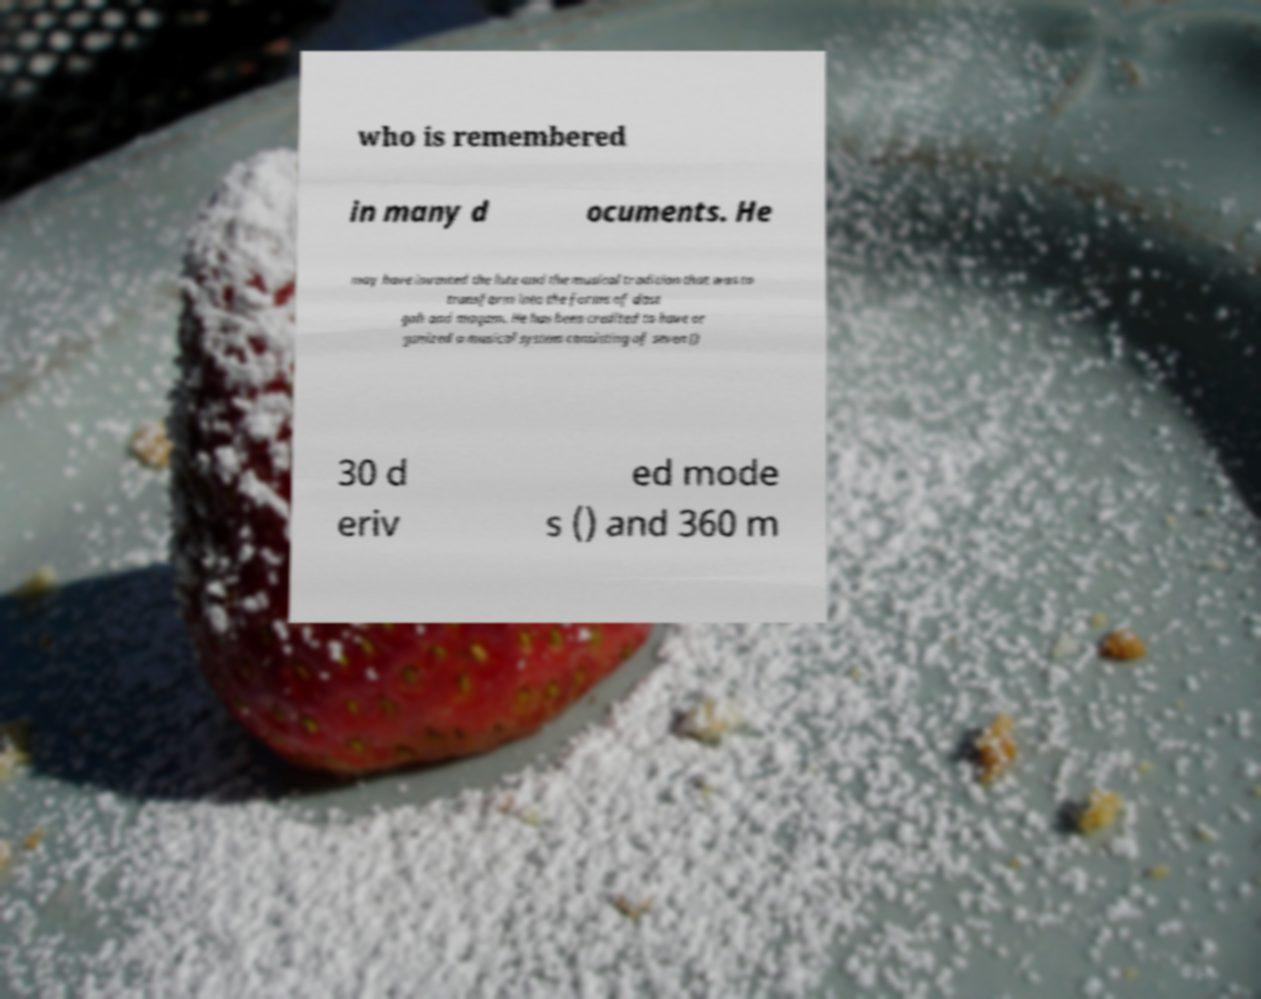Can you accurately transcribe the text from the provided image for me? who is remembered in many d ocuments. He may have invented the lute and the musical tradition that was to transform into the forms of dast gah and maqam. He has been credited to have or ganized a musical system consisting of seven () 30 d eriv ed mode s () and 360 m 